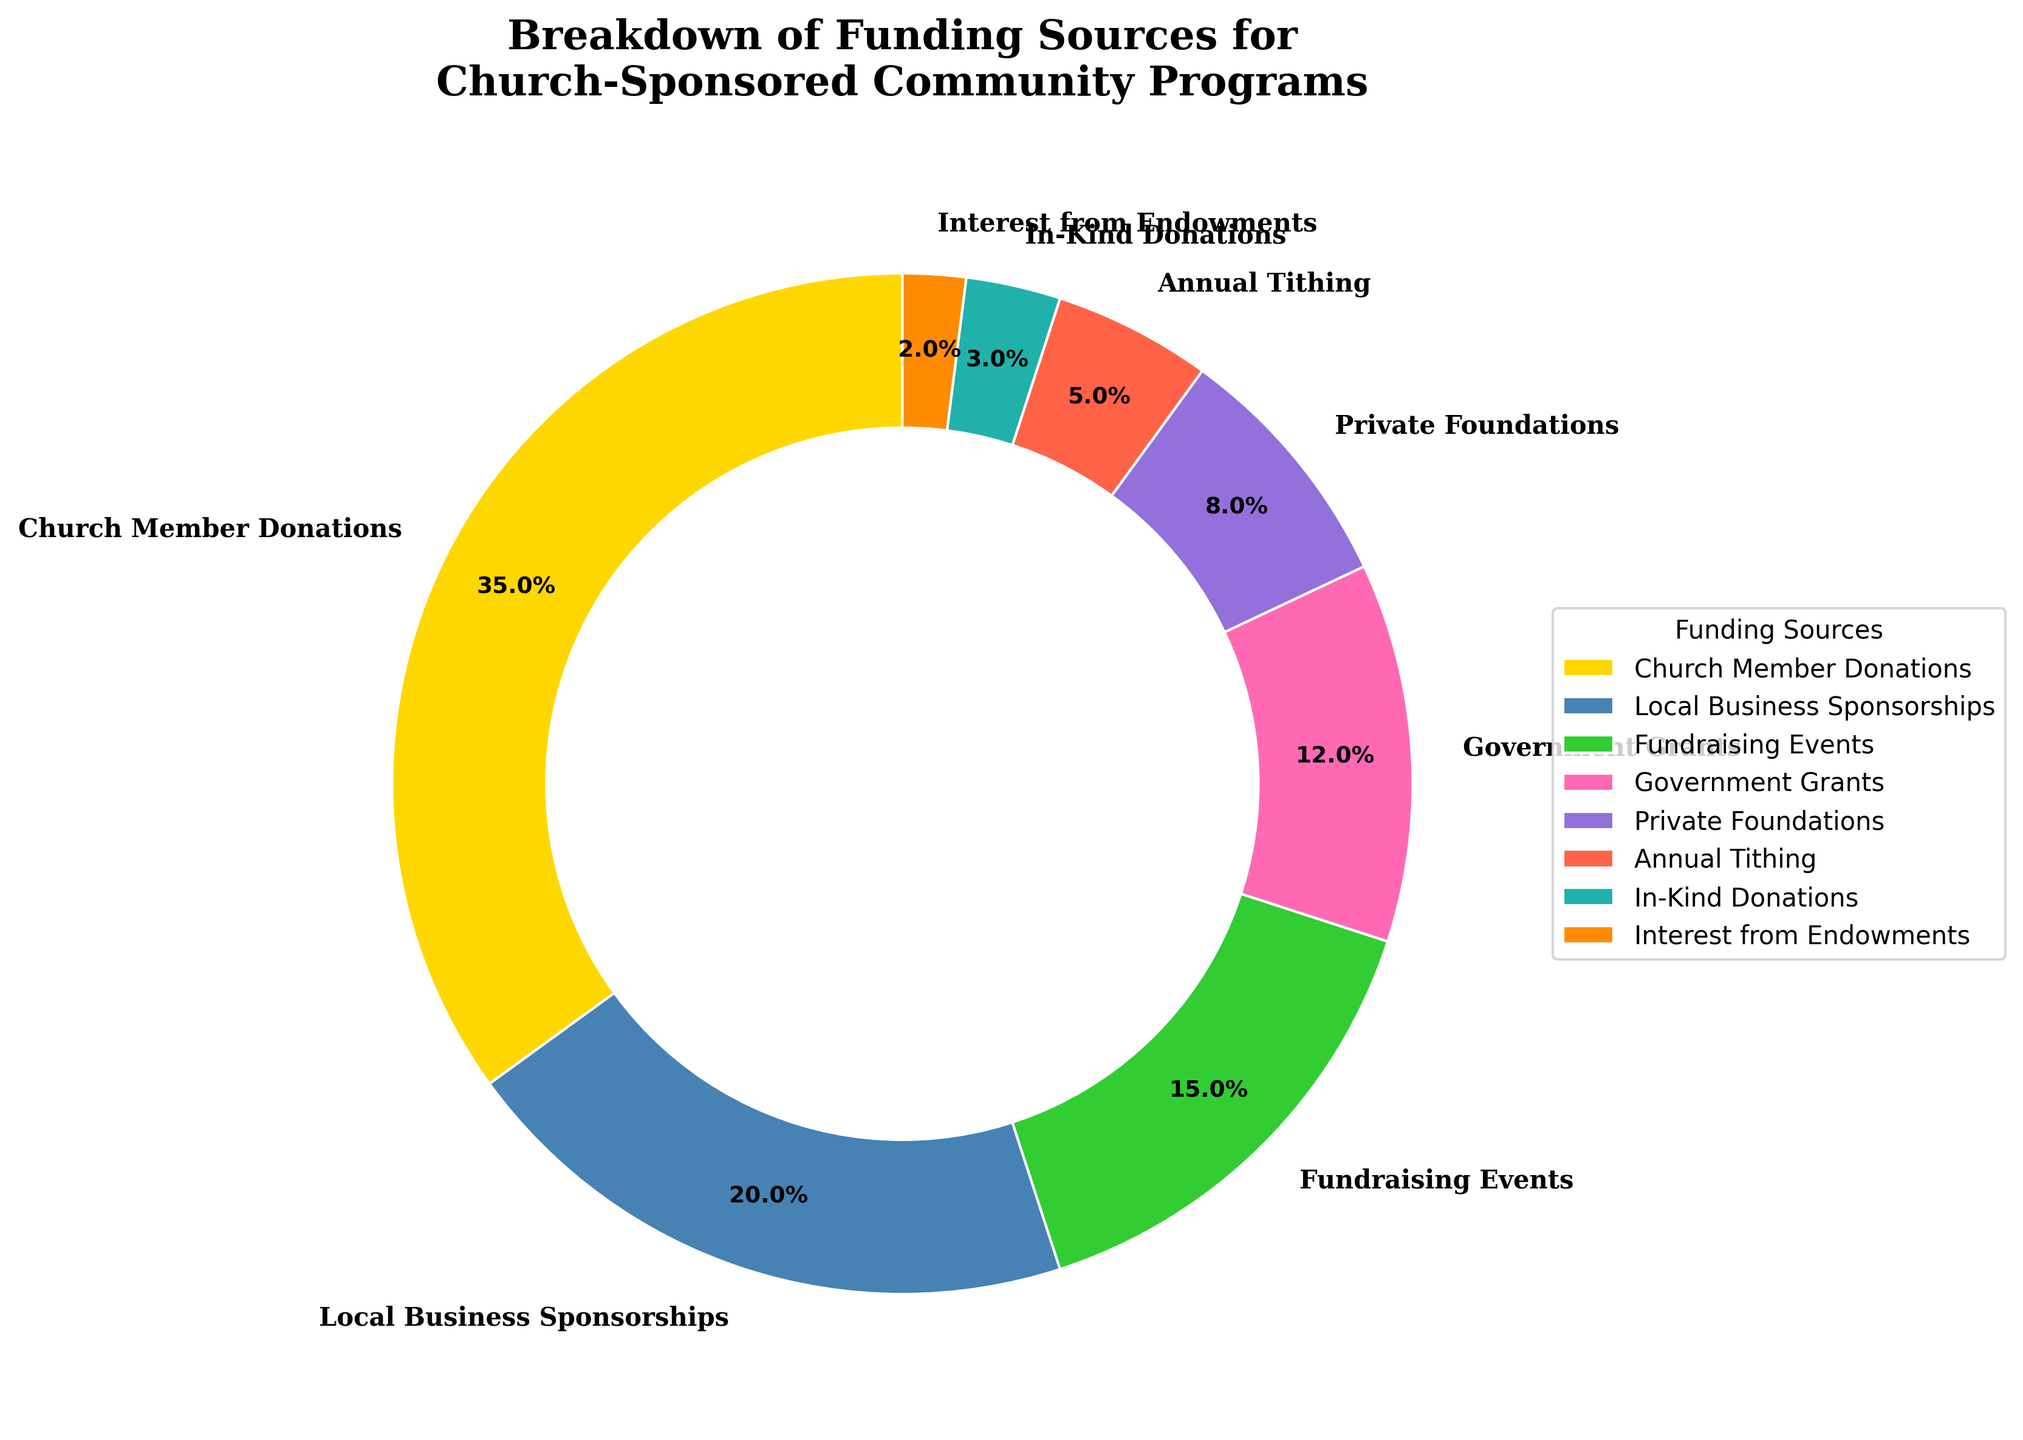What percentage of the funding comes from Government Grants and Private Foundations combined? Adding the percentages for Government Grants (12%) and Private Foundations (8%) gives us 20%.
Answer: 20% Which funding source contributes the least to the total funding? The funding source with the smallest percentage in the chart is Interest from Endowments (2%).
Answer: Interest from Endowments Is the contribution from Church Member Donations greater than the combined contributions of Fundraising Events and In-Kind Donations? Church Member Donations is 35%, while Fundraising Events (15%) and In-Kind Donations (3%) add up to 18%. Since 35% is greater than 18%, the contribution from Church Member Donations is indeed greater.
Answer: Yes How does the percentage from Local Business Sponsorships compare to that from Fundraising Events and Annual Tithing? Local Business Sponsorships contribute 20%, while Fundraising Events and Annual Tithing together contribute 15% + 5% = 20%. The contributions are equal.
Answer: Equal What is the visual attribute of the wedge representing Annual Tithing? The wedge representing Annual Tithing appears smaller in arc length compared to others and is colored in a different hue, likely a warm tone (e.g., orange or red).
Answer: Smaller arc length, warm color Among the largest three funding sources, what is the percentage difference between the largest and the third-largest source? The largest is Church Member Donations (35%), and the third largest is Fundraising Events (15%). The difference is 35% - 15% = 20%.
Answer: 20% If you sum the contributions of Local Business Sponsorships, Private Foundations, and Interest from Endowments, do they account for more than 30% of the total funding? Adding Local Business Sponsorships (20%), Private Foundations (8%), and Interest from Endowments (2%) gives us 20% + 8% + 2% = 30%.
Answer: No Identify two funding sources whose combined contribution is equal to the contribution from Local Business Sponsorships. Fundraising Events (15%) and Annual Tithing (5%) combined are 15% + 5% = 20%, which equals the contribution from Local Business Sponsorships.
Answer: Fundraising Events and Annual Tithing Which three funding sources collectively provide more than 50% of the funding? Church Member Donations (35%), Local Business Sponsorships (20%), and Fundraising Events (15%) collectively provide 35% + 20% + 15% = 70%, which is more than 50%.
Answer: Church Member Donations, Local Business Sponsorships, Fundraising Events 